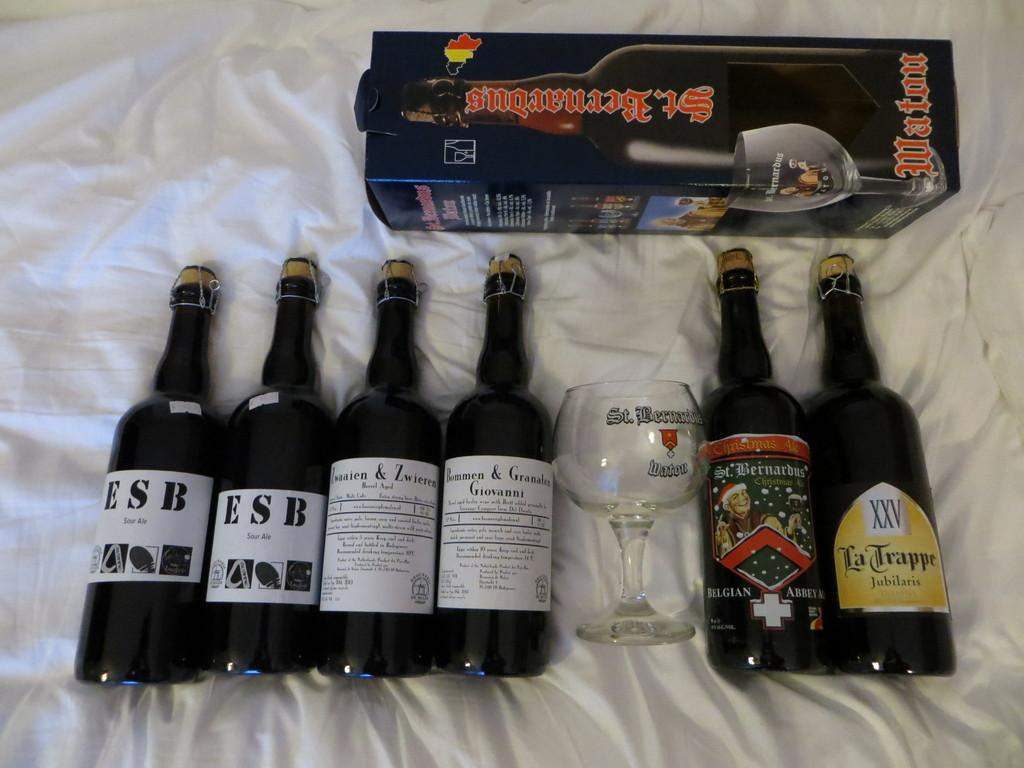<image>
Share a concise interpretation of the image provided. Several bottles of ale sitting with a glass on a white sheet. 